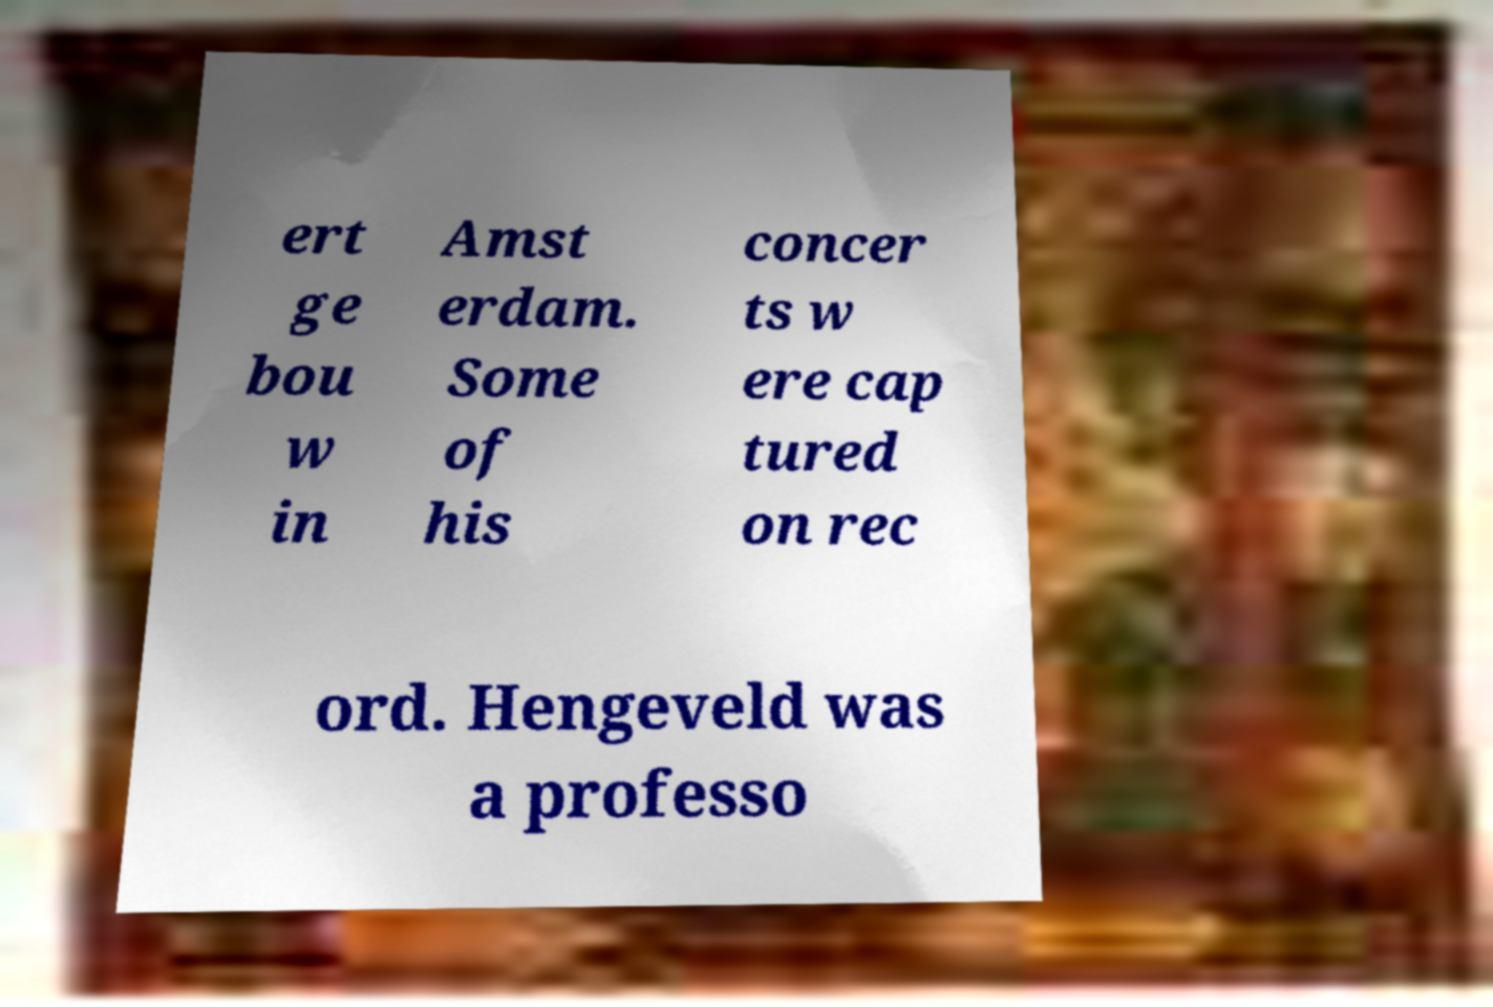I need the written content from this picture converted into text. Can you do that? ert ge bou w in Amst erdam. Some of his concer ts w ere cap tured on rec ord. Hengeveld was a professo 